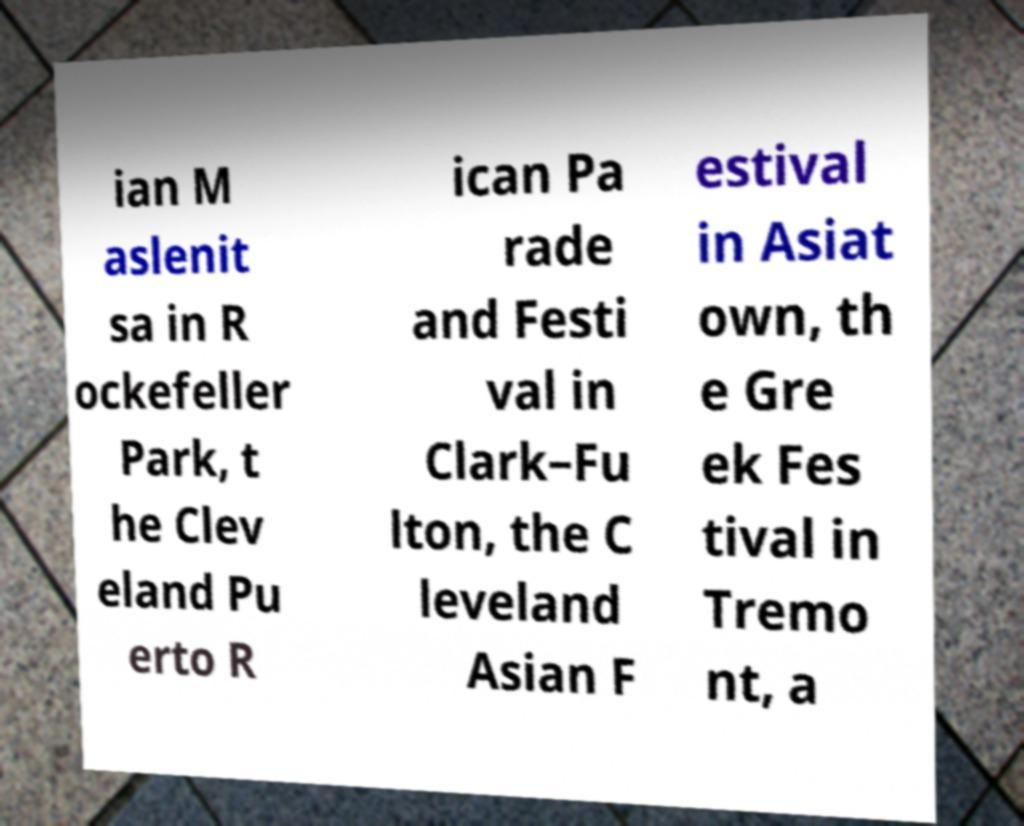Please identify and transcribe the text found in this image. ian M aslenit sa in R ockefeller Park, t he Clev eland Pu erto R ican Pa rade and Festi val in Clark–Fu lton, the C leveland Asian F estival in Asiat own, th e Gre ek Fes tival in Tremo nt, a 